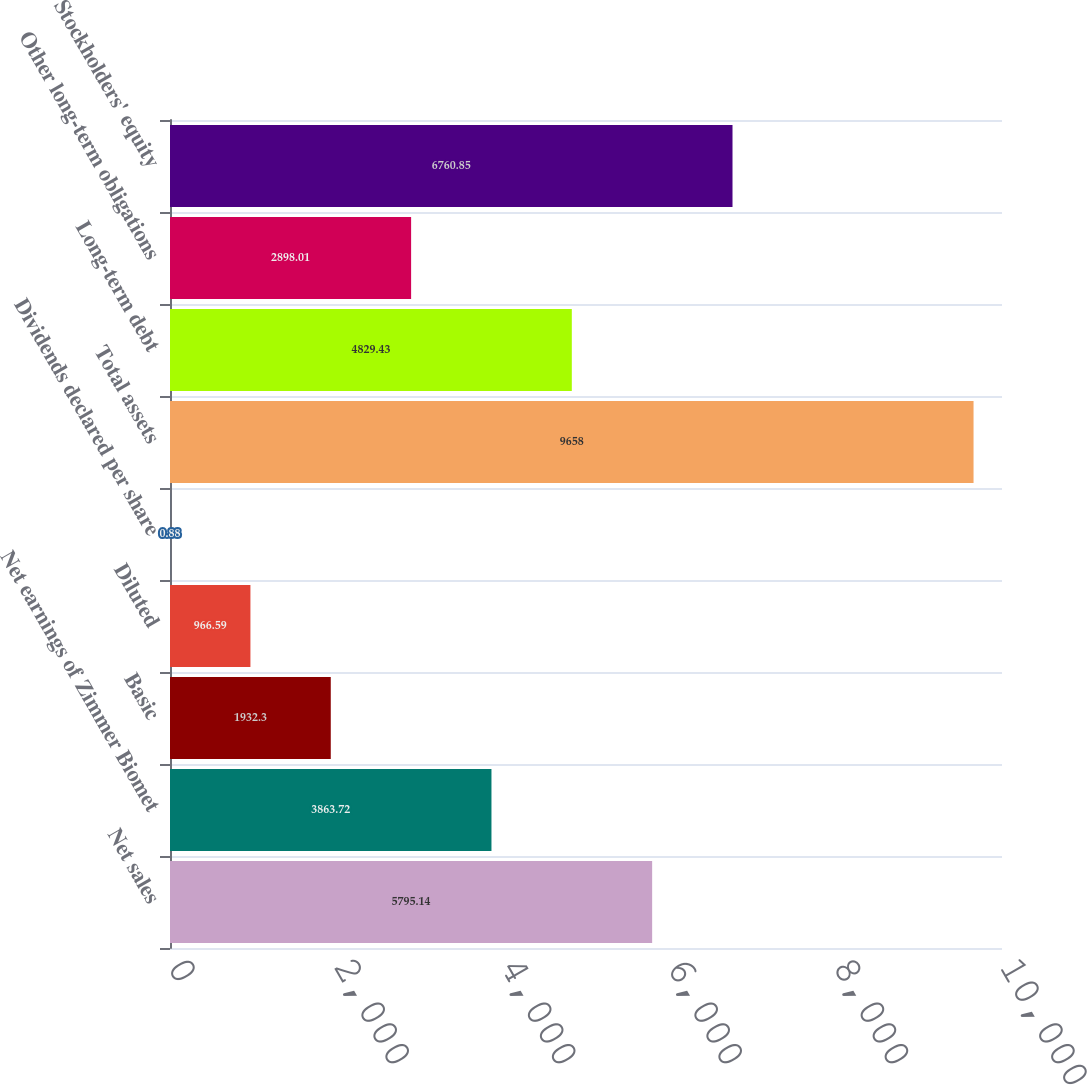Convert chart. <chart><loc_0><loc_0><loc_500><loc_500><bar_chart><fcel>Net sales<fcel>Net earnings of Zimmer Biomet<fcel>Basic<fcel>Diluted<fcel>Dividends declared per share<fcel>Total assets<fcel>Long-term debt<fcel>Other long-term obligations<fcel>Stockholders' equity<nl><fcel>5795.14<fcel>3863.72<fcel>1932.3<fcel>966.59<fcel>0.88<fcel>9658<fcel>4829.43<fcel>2898.01<fcel>6760.85<nl></chart> 